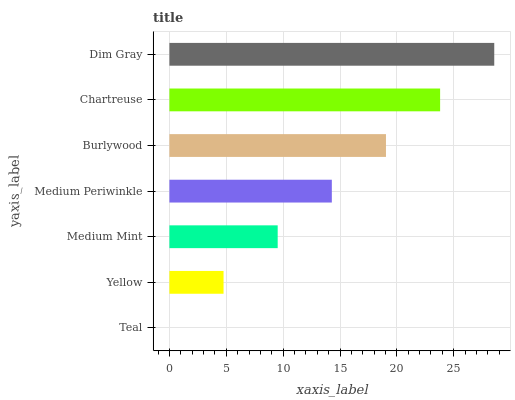Is Teal the minimum?
Answer yes or no. Yes. Is Dim Gray the maximum?
Answer yes or no. Yes. Is Yellow the minimum?
Answer yes or no. No. Is Yellow the maximum?
Answer yes or no. No. Is Yellow greater than Teal?
Answer yes or no. Yes. Is Teal less than Yellow?
Answer yes or no. Yes. Is Teal greater than Yellow?
Answer yes or no. No. Is Yellow less than Teal?
Answer yes or no. No. Is Medium Periwinkle the high median?
Answer yes or no. Yes. Is Medium Periwinkle the low median?
Answer yes or no. Yes. Is Dim Gray the high median?
Answer yes or no. No. Is Yellow the low median?
Answer yes or no. No. 